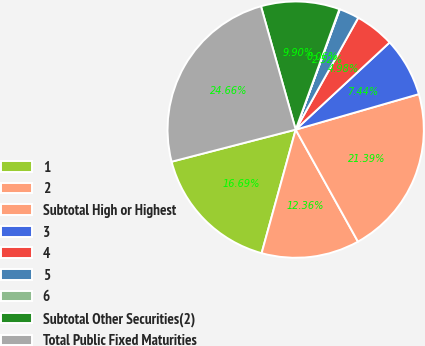Convert chart. <chart><loc_0><loc_0><loc_500><loc_500><pie_chart><fcel>1<fcel>2<fcel>Subtotal High or Highest<fcel>3<fcel>4<fcel>5<fcel>6<fcel>Subtotal Other Securities(2)<fcel>Total Public Fixed Maturities<nl><fcel>16.69%<fcel>12.36%<fcel>21.39%<fcel>7.44%<fcel>4.98%<fcel>2.52%<fcel>0.06%<fcel>9.9%<fcel>24.66%<nl></chart> 